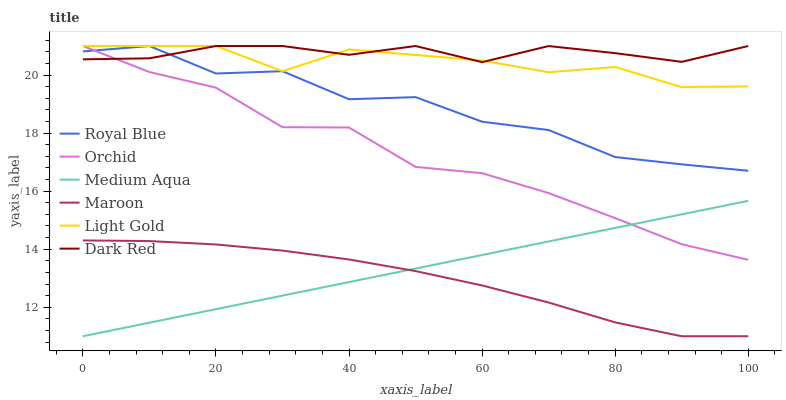Does Maroon have the minimum area under the curve?
Answer yes or no. Yes. Does Dark Red have the maximum area under the curve?
Answer yes or no. Yes. Does Royal Blue have the minimum area under the curve?
Answer yes or no. No. Does Royal Blue have the maximum area under the curve?
Answer yes or no. No. Is Medium Aqua the smoothest?
Answer yes or no. Yes. Is Royal Blue the roughest?
Answer yes or no. Yes. Is Maroon the smoothest?
Answer yes or no. No. Is Maroon the roughest?
Answer yes or no. No. Does Maroon have the lowest value?
Answer yes or no. Yes. Does Royal Blue have the lowest value?
Answer yes or no. No. Does Orchid have the highest value?
Answer yes or no. Yes. Does Maroon have the highest value?
Answer yes or no. No. Is Medium Aqua less than Royal Blue?
Answer yes or no. Yes. Is Light Gold greater than Medium Aqua?
Answer yes or no. Yes. Does Dark Red intersect Orchid?
Answer yes or no. Yes. Is Dark Red less than Orchid?
Answer yes or no. No. Is Dark Red greater than Orchid?
Answer yes or no. No. Does Medium Aqua intersect Royal Blue?
Answer yes or no. No. 